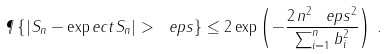Convert formula to latex. <formula><loc_0><loc_0><loc_500><loc_500>\P \left \{ | S _ { n } - \exp e c t S _ { n } | > \ e p s \right \} \leq 2 \exp \left ( - \frac { 2 \, n ^ { 2 } \, \ e p s ^ { 2 } } { \sum _ { i = 1 } ^ { n } b _ { i } ^ { 2 } } \right ) \, .</formula> 